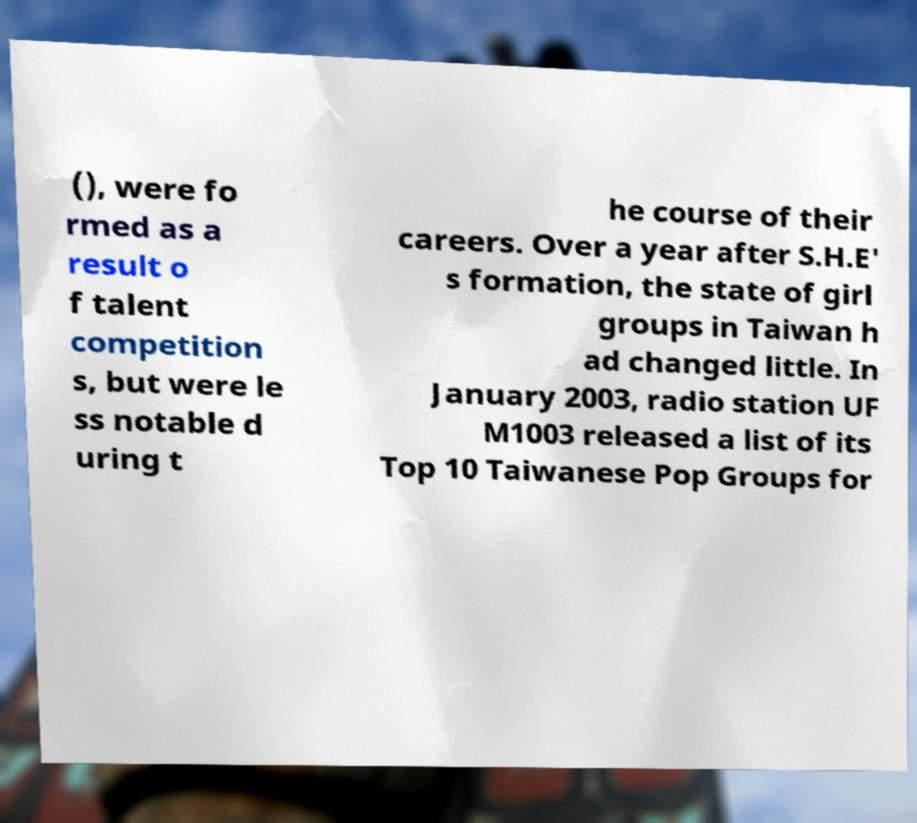Could you extract and type out the text from this image? (), were fo rmed as a result o f talent competition s, but were le ss notable d uring t he course of their careers. Over a year after S.H.E' s formation, the state of girl groups in Taiwan h ad changed little. In January 2003, radio station UF M1003 released a list of its Top 10 Taiwanese Pop Groups for 